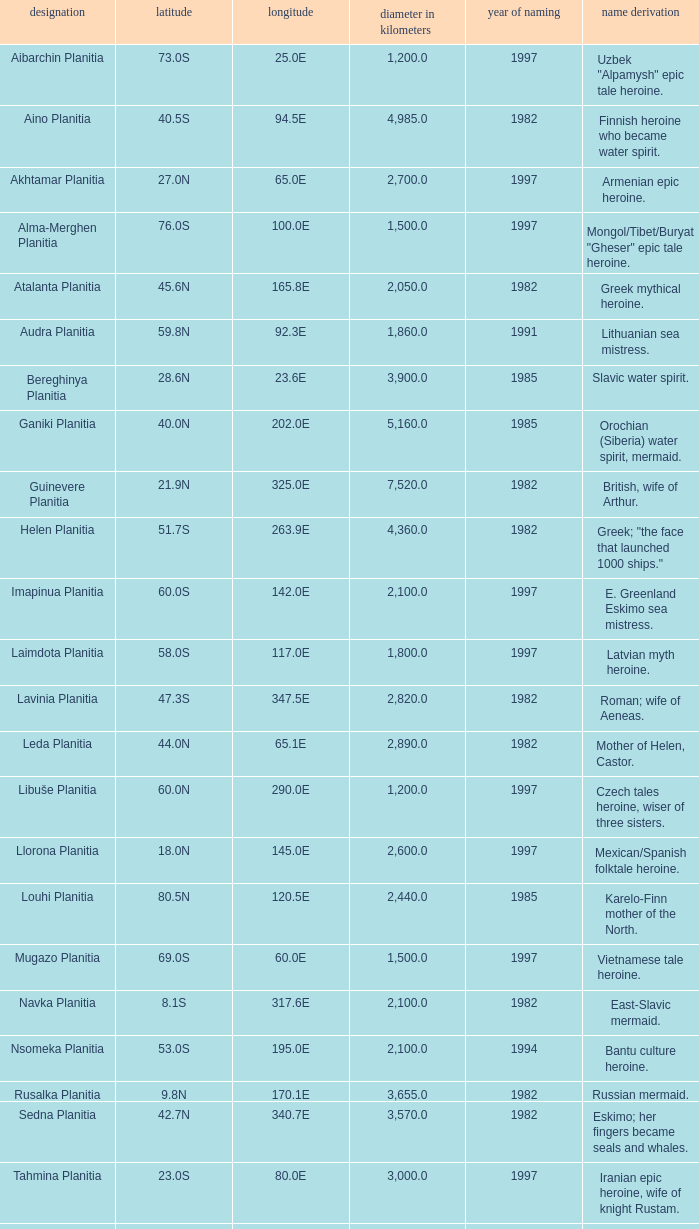What is the diameter (km) of longitude 170.1e 3655.0. 